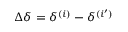Convert formula to latex. <formula><loc_0><loc_0><loc_500><loc_500>\Delta \delta = \delta ^ { ( i ) } - \delta ^ { ( i ^ { \prime } ) }</formula> 